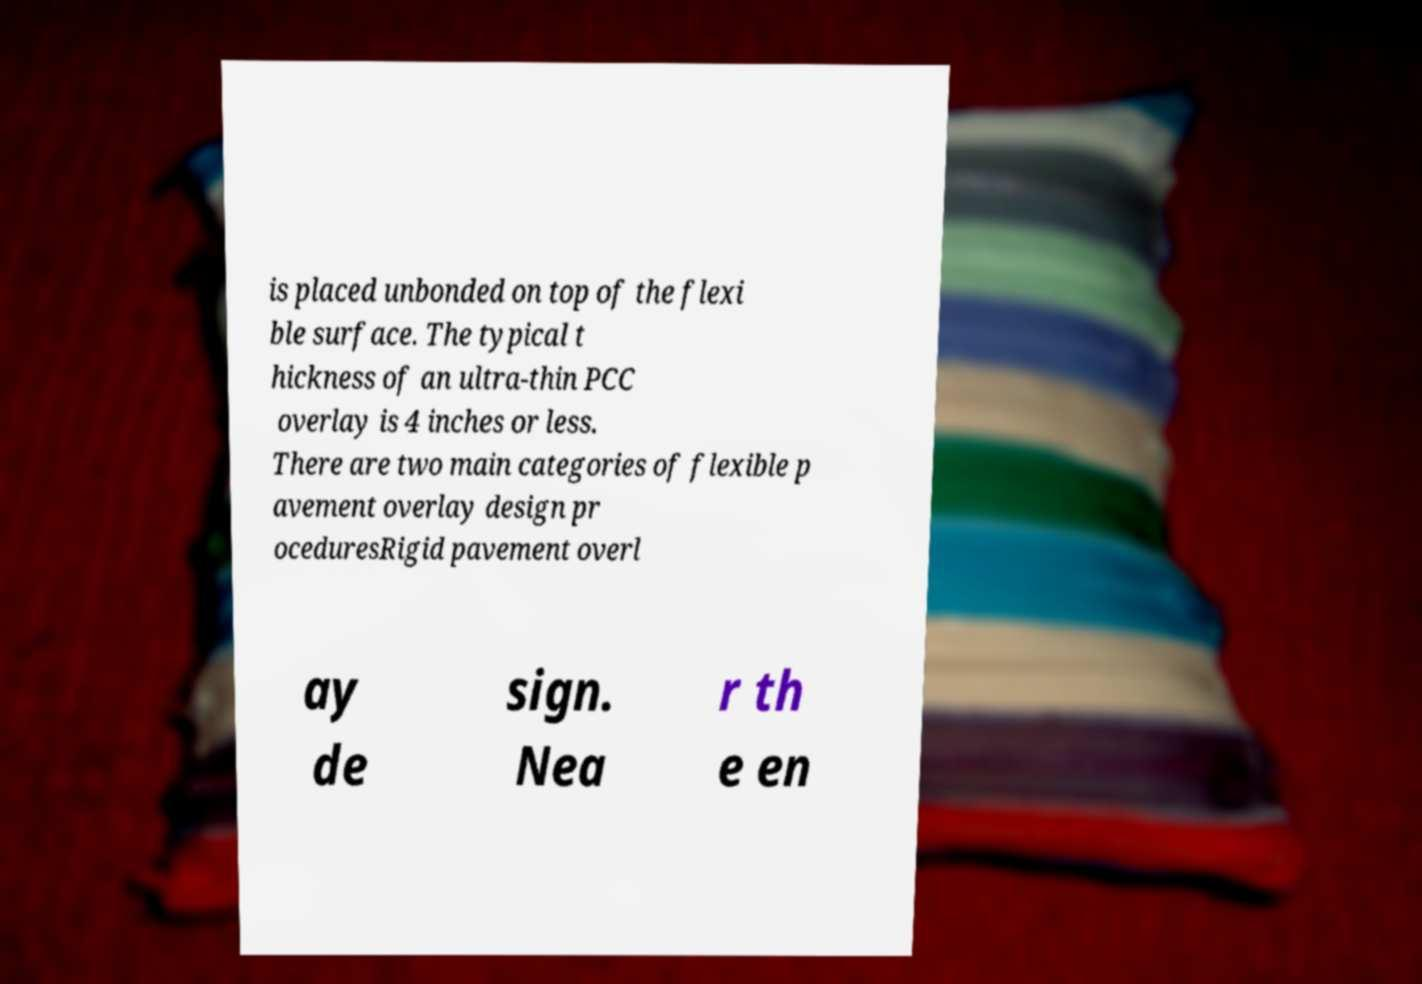What messages or text are displayed in this image? I need them in a readable, typed format. is placed unbonded on top of the flexi ble surface. The typical t hickness of an ultra-thin PCC overlay is 4 inches or less. There are two main categories of flexible p avement overlay design pr oceduresRigid pavement overl ay de sign. Nea r th e en 